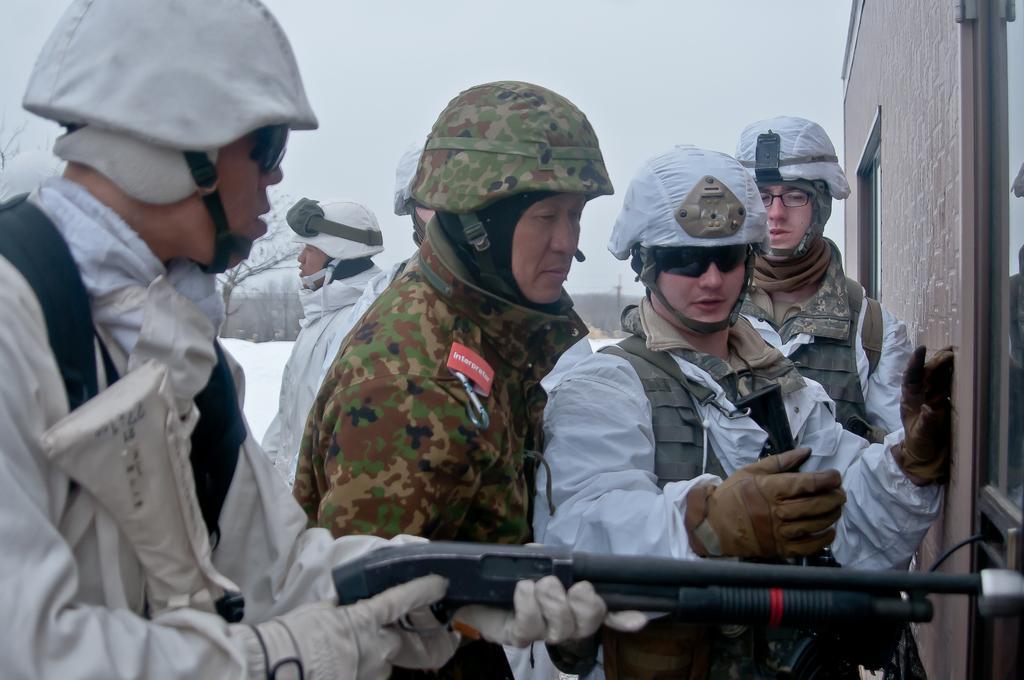Describe this image in one or two sentences. In the picture I can see few persons wearing helmets are standing and there is a building in the right corner and there are few trees in the background. 